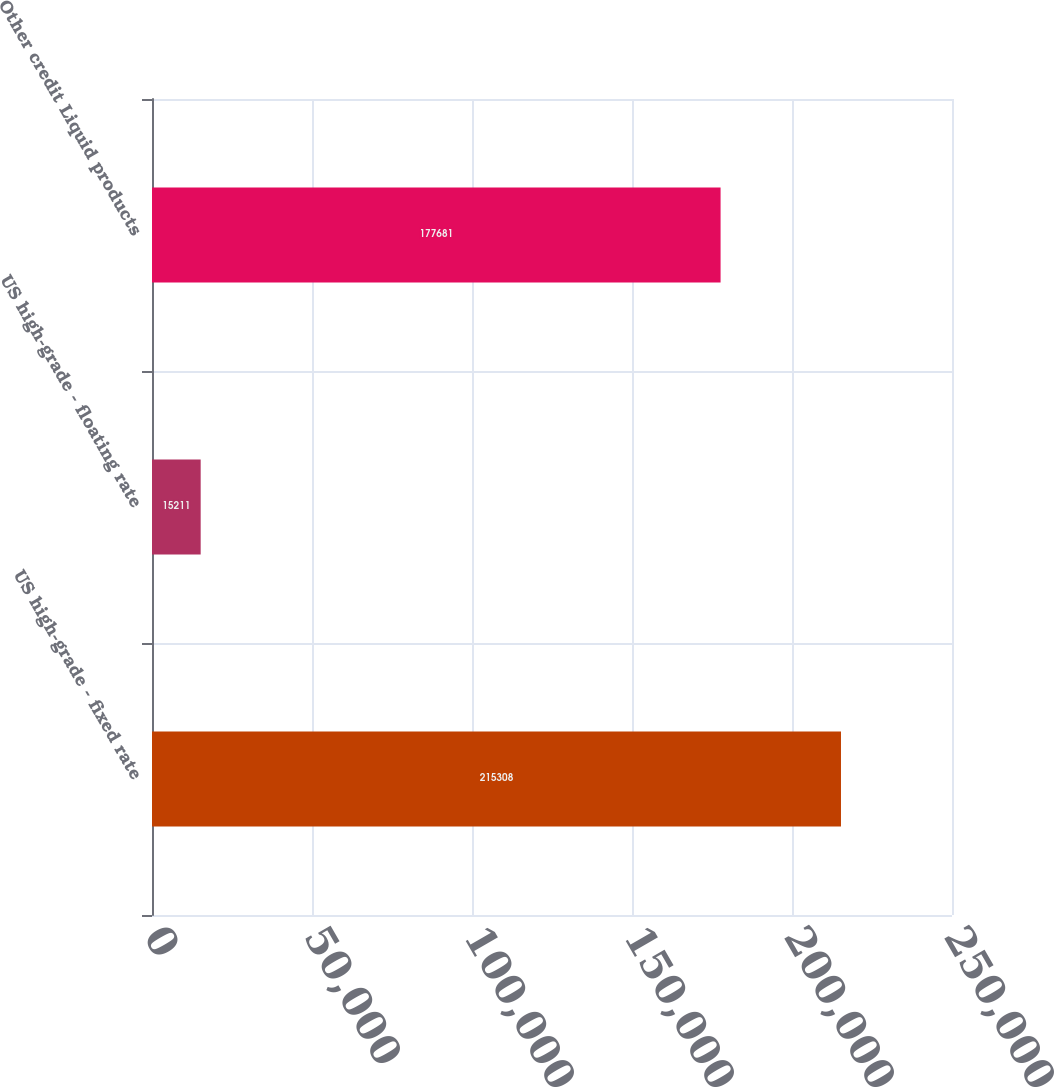Convert chart to OTSL. <chart><loc_0><loc_0><loc_500><loc_500><bar_chart><fcel>US high-grade - fixed rate<fcel>US high-grade - floating rate<fcel>Other credit Liquid products<nl><fcel>215308<fcel>15211<fcel>177681<nl></chart> 